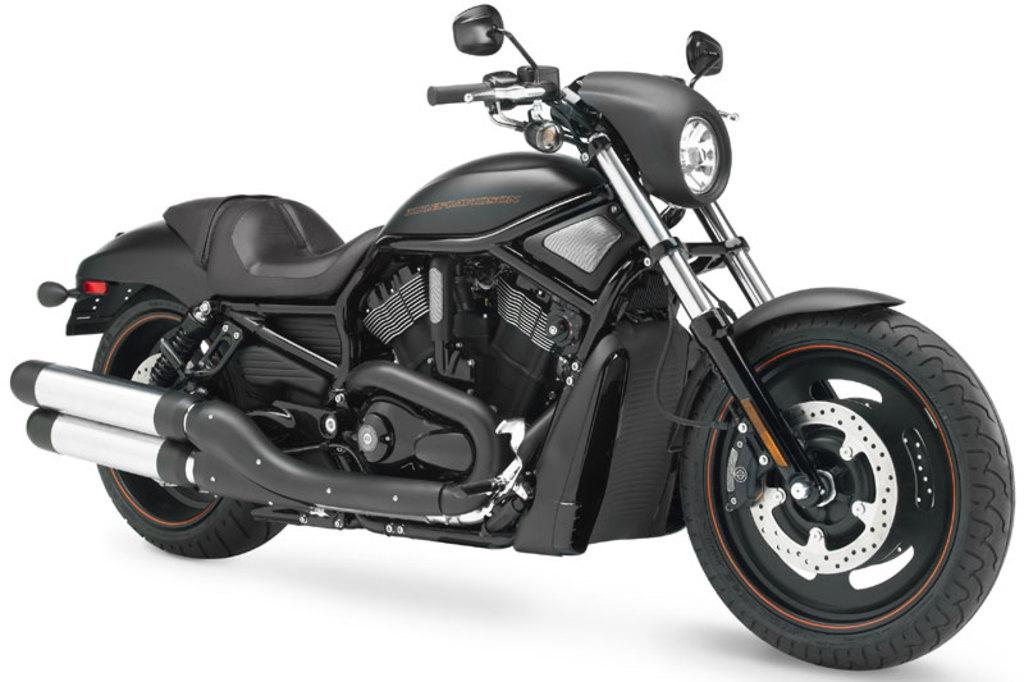What is the main subject of the image? There is a vehicle in the image. What statement does the beggar make while wearing jeans in the image? There is no beggar or jeans present in the image; it only features a vehicle. 